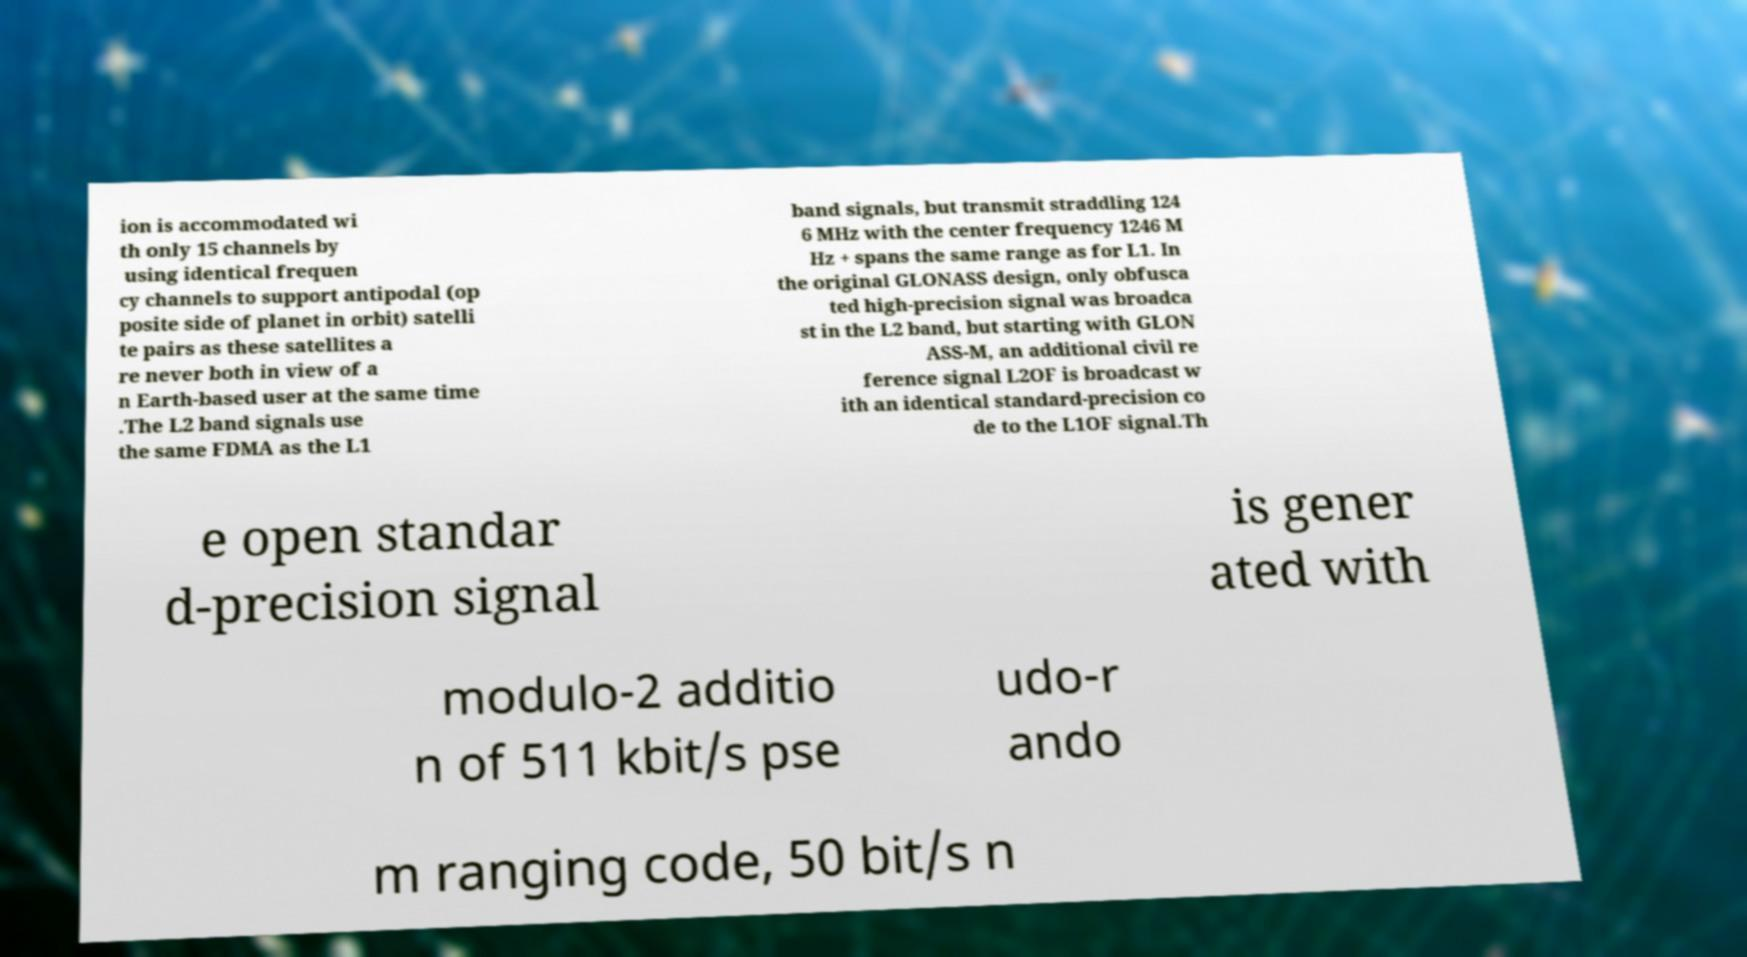Could you assist in decoding the text presented in this image and type it out clearly? ion is accommodated wi th only 15 channels by using identical frequen cy channels to support antipodal (op posite side of planet in orbit) satelli te pairs as these satellites a re never both in view of a n Earth-based user at the same time .The L2 band signals use the same FDMA as the L1 band signals, but transmit straddling 124 6 MHz with the center frequency 1246 M Hz + spans the same range as for L1. In the original GLONASS design, only obfusca ted high-precision signal was broadca st in the L2 band, but starting with GLON ASS-M, an additional civil re ference signal L2OF is broadcast w ith an identical standard-precision co de to the L1OF signal.Th e open standar d-precision signal is gener ated with modulo-2 additio n of 511 kbit/s pse udo-r ando m ranging code, 50 bit/s n 